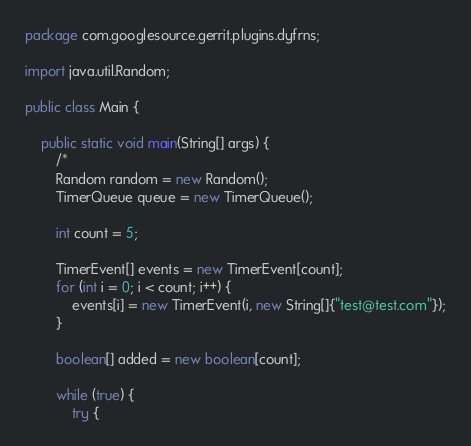<code> <loc_0><loc_0><loc_500><loc_500><_Java_>package com.googlesource.gerrit.plugins.dyfrns;

import java.util.Random;

public class Main {

    public static void main(String[] args) {
        /*
        Random random = new Random();
        TimerQueue queue = new TimerQueue();

        int count = 5;

        TimerEvent[] events = new TimerEvent[count];
        for (int i = 0; i < count; i++) {
            events[i] = new TimerEvent(i, new String[]{"test@test.com"});
        }

        boolean[] added = new boolean[count];

        while (true) {
            try {</code> 